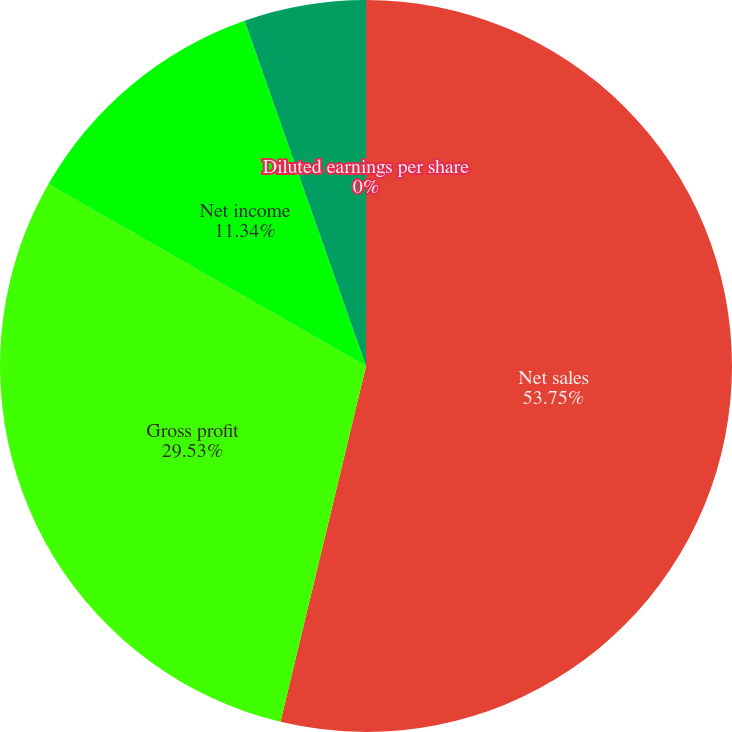Convert chart to OTSL. <chart><loc_0><loc_0><loc_500><loc_500><pie_chart><fcel>Net sales<fcel>Gross profit<fcel>Net income<fcel>Basic earnings per share<fcel>Diluted earnings per share<nl><fcel>53.76%<fcel>29.53%<fcel>11.34%<fcel>5.38%<fcel>0.0%<nl></chart> 